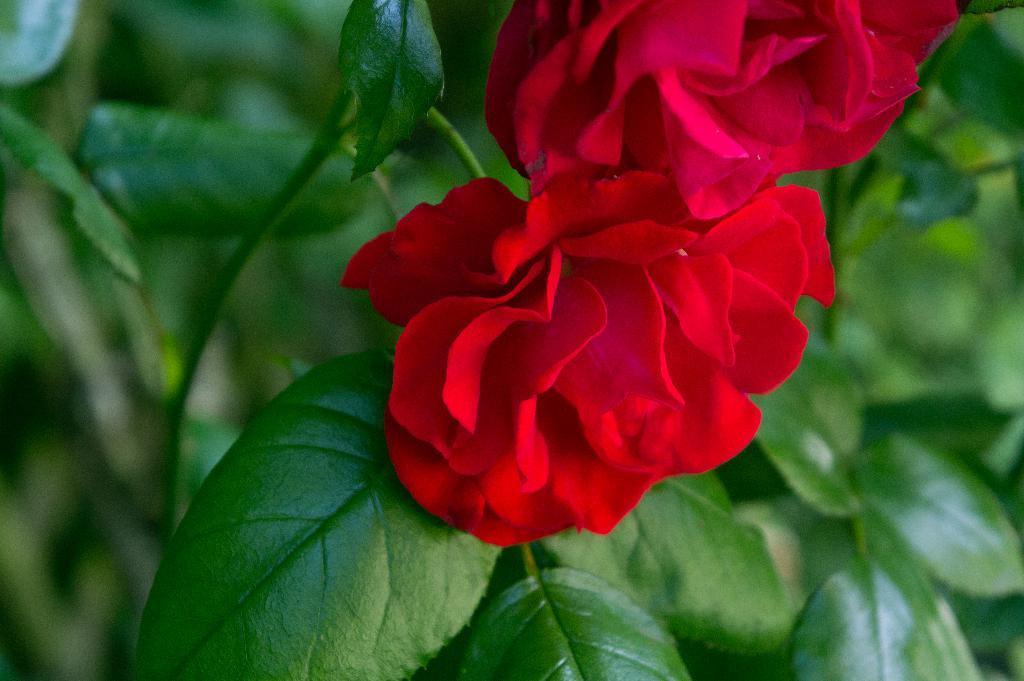Can you describe this image briefly? In this image we can see flowers and plants. 